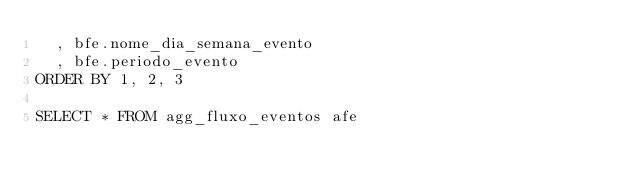Convert code to text. <code><loc_0><loc_0><loc_500><loc_500><_SQL_>	, bfe.nome_dia_semana_evento
	, bfe.periodo_evento
ORDER BY 1, 2, 3

SELECT * FROM agg_fluxo_eventos afe </code> 